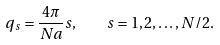<formula> <loc_0><loc_0><loc_500><loc_500>q _ { s } = \frac { 4 \pi } { N a } s , \quad s = 1 , 2 , \dots , N / 2 .</formula> 